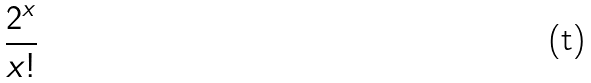<formula> <loc_0><loc_0><loc_500><loc_500>\frac { 2 ^ { x } } { x ! }</formula> 